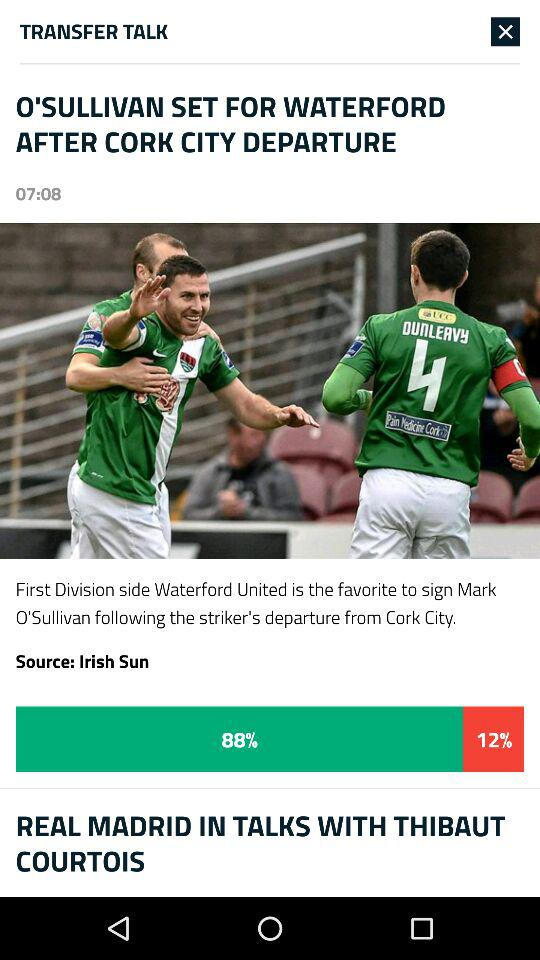What is the difference between the popularity of the two stories?
Answer the question using a single word or phrase. 76% 